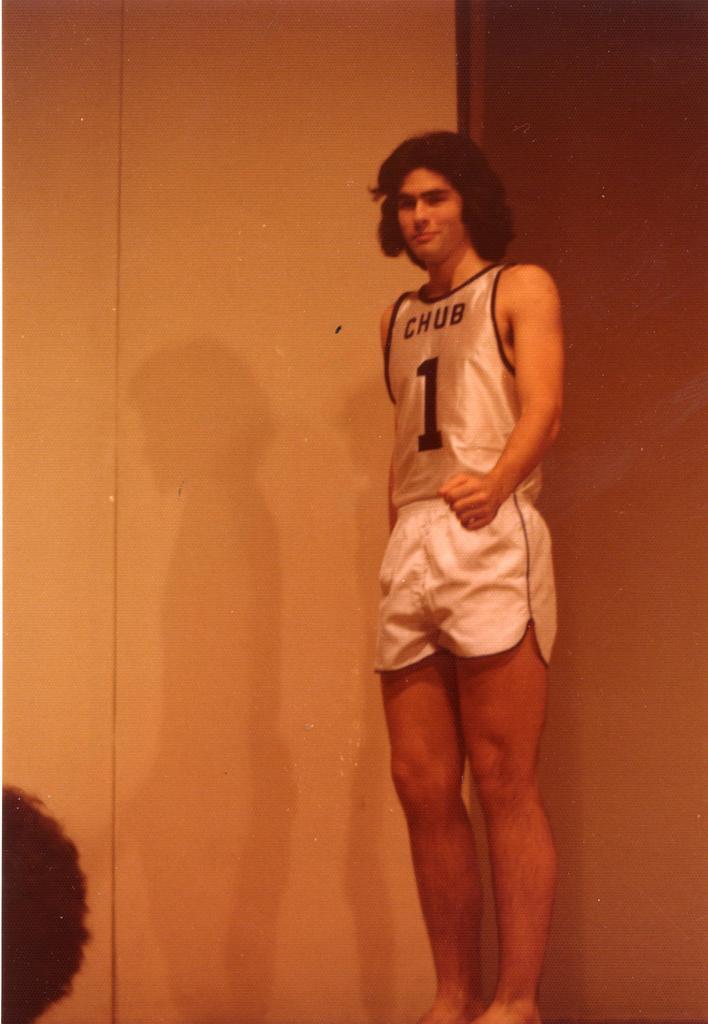What team does he play for?
Your answer should be very brief. Chub. What number is on the shirt?
Make the answer very short. 1. 